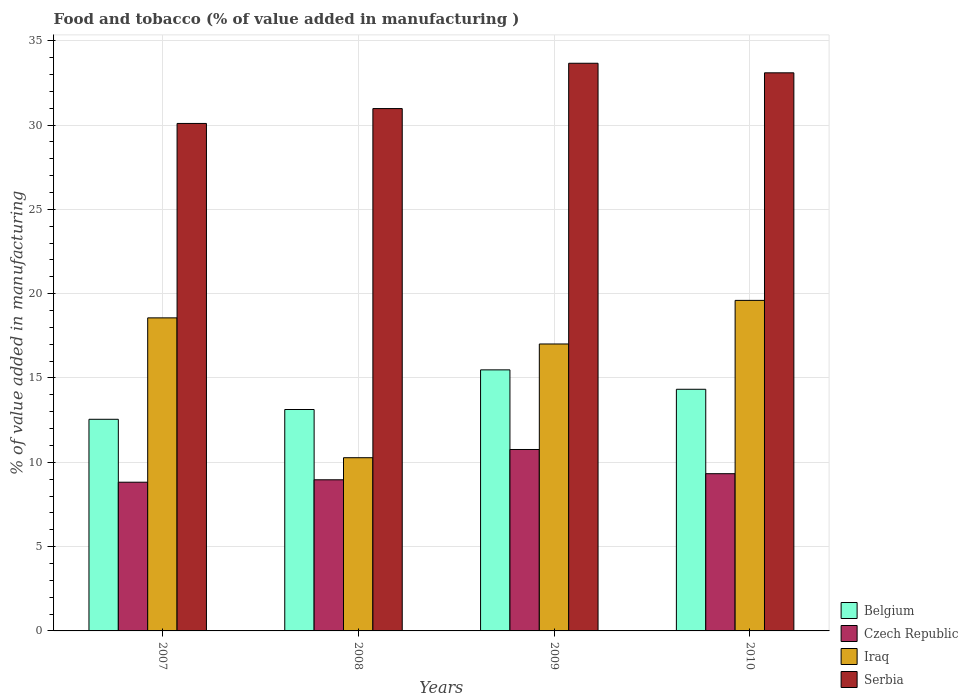Are the number of bars per tick equal to the number of legend labels?
Provide a succinct answer. Yes. How many bars are there on the 4th tick from the left?
Provide a succinct answer. 4. What is the value added in manufacturing food and tobacco in Iraq in 2009?
Your answer should be very brief. 17.02. Across all years, what is the maximum value added in manufacturing food and tobacco in Czech Republic?
Provide a short and direct response. 10.76. Across all years, what is the minimum value added in manufacturing food and tobacco in Czech Republic?
Make the answer very short. 8.82. What is the total value added in manufacturing food and tobacco in Czech Republic in the graph?
Provide a short and direct response. 37.86. What is the difference between the value added in manufacturing food and tobacco in Czech Republic in 2008 and that in 2010?
Provide a short and direct response. -0.36. What is the difference between the value added in manufacturing food and tobacco in Belgium in 2010 and the value added in manufacturing food and tobacco in Serbia in 2009?
Your response must be concise. -19.33. What is the average value added in manufacturing food and tobacco in Belgium per year?
Your answer should be very brief. 13.87. In the year 2008, what is the difference between the value added in manufacturing food and tobacco in Iraq and value added in manufacturing food and tobacco in Czech Republic?
Give a very brief answer. 1.31. What is the ratio of the value added in manufacturing food and tobacco in Czech Republic in 2007 to that in 2009?
Provide a succinct answer. 0.82. Is the value added in manufacturing food and tobacco in Belgium in 2008 less than that in 2009?
Offer a very short reply. Yes. Is the difference between the value added in manufacturing food and tobacco in Iraq in 2009 and 2010 greater than the difference between the value added in manufacturing food and tobacco in Czech Republic in 2009 and 2010?
Keep it short and to the point. No. What is the difference between the highest and the second highest value added in manufacturing food and tobacco in Belgium?
Your response must be concise. 1.15. What is the difference between the highest and the lowest value added in manufacturing food and tobacco in Belgium?
Your response must be concise. 2.93. In how many years, is the value added in manufacturing food and tobacco in Czech Republic greater than the average value added in manufacturing food and tobacco in Czech Republic taken over all years?
Your response must be concise. 1. Is it the case that in every year, the sum of the value added in manufacturing food and tobacco in Czech Republic and value added in manufacturing food and tobacco in Belgium is greater than the sum of value added in manufacturing food and tobacco in Iraq and value added in manufacturing food and tobacco in Serbia?
Your answer should be compact. Yes. What does the 1st bar from the left in 2009 represents?
Provide a succinct answer. Belgium. What does the 4th bar from the right in 2009 represents?
Give a very brief answer. Belgium. How many bars are there?
Offer a very short reply. 16. Are all the bars in the graph horizontal?
Make the answer very short. No. How many years are there in the graph?
Your answer should be very brief. 4. What is the difference between two consecutive major ticks on the Y-axis?
Your response must be concise. 5. Does the graph contain any zero values?
Your answer should be very brief. No. How are the legend labels stacked?
Provide a short and direct response. Vertical. What is the title of the graph?
Give a very brief answer. Food and tobacco (% of value added in manufacturing ). Does "Kenya" appear as one of the legend labels in the graph?
Your response must be concise. No. What is the label or title of the Y-axis?
Offer a very short reply. % of value added in manufacturing. What is the % of value added in manufacturing of Belgium in 2007?
Offer a terse response. 12.55. What is the % of value added in manufacturing of Czech Republic in 2007?
Offer a very short reply. 8.82. What is the % of value added in manufacturing of Iraq in 2007?
Offer a very short reply. 18.56. What is the % of value added in manufacturing of Serbia in 2007?
Your response must be concise. 30.09. What is the % of value added in manufacturing in Belgium in 2008?
Provide a succinct answer. 13.13. What is the % of value added in manufacturing in Czech Republic in 2008?
Provide a short and direct response. 8.96. What is the % of value added in manufacturing in Iraq in 2008?
Provide a succinct answer. 10.27. What is the % of value added in manufacturing in Serbia in 2008?
Make the answer very short. 30.97. What is the % of value added in manufacturing of Belgium in 2009?
Make the answer very short. 15.48. What is the % of value added in manufacturing of Czech Republic in 2009?
Your response must be concise. 10.76. What is the % of value added in manufacturing in Iraq in 2009?
Your response must be concise. 17.02. What is the % of value added in manufacturing in Serbia in 2009?
Your response must be concise. 33.66. What is the % of value added in manufacturing of Belgium in 2010?
Give a very brief answer. 14.33. What is the % of value added in manufacturing in Czech Republic in 2010?
Provide a short and direct response. 9.32. What is the % of value added in manufacturing of Iraq in 2010?
Your answer should be compact. 19.6. What is the % of value added in manufacturing in Serbia in 2010?
Your response must be concise. 33.09. Across all years, what is the maximum % of value added in manufacturing in Belgium?
Provide a succinct answer. 15.48. Across all years, what is the maximum % of value added in manufacturing in Czech Republic?
Give a very brief answer. 10.76. Across all years, what is the maximum % of value added in manufacturing of Iraq?
Provide a short and direct response. 19.6. Across all years, what is the maximum % of value added in manufacturing of Serbia?
Your answer should be compact. 33.66. Across all years, what is the minimum % of value added in manufacturing of Belgium?
Ensure brevity in your answer.  12.55. Across all years, what is the minimum % of value added in manufacturing in Czech Republic?
Make the answer very short. 8.82. Across all years, what is the minimum % of value added in manufacturing of Iraq?
Your response must be concise. 10.27. Across all years, what is the minimum % of value added in manufacturing of Serbia?
Your response must be concise. 30.09. What is the total % of value added in manufacturing of Belgium in the graph?
Offer a terse response. 55.49. What is the total % of value added in manufacturing of Czech Republic in the graph?
Your answer should be very brief. 37.86. What is the total % of value added in manufacturing in Iraq in the graph?
Keep it short and to the point. 65.45. What is the total % of value added in manufacturing in Serbia in the graph?
Offer a very short reply. 127.82. What is the difference between the % of value added in manufacturing of Belgium in 2007 and that in 2008?
Provide a succinct answer. -0.58. What is the difference between the % of value added in manufacturing of Czech Republic in 2007 and that in 2008?
Ensure brevity in your answer.  -0.14. What is the difference between the % of value added in manufacturing in Iraq in 2007 and that in 2008?
Offer a terse response. 8.29. What is the difference between the % of value added in manufacturing of Serbia in 2007 and that in 2008?
Ensure brevity in your answer.  -0.88. What is the difference between the % of value added in manufacturing in Belgium in 2007 and that in 2009?
Provide a succinct answer. -2.93. What is the difference between the % of value added in manufacturing of Czech Republic in 2007 and that in 2009?
Your answer should be very brief. -1.94. What is the difference between the % of value added in manufacturing in Iraq in 2007 and that in 2009?
Your answer should be compact. 1.55. What is the difference between the % of value added in manufacturing in Serbia in 2007 and that in 2009?
Your response must be concise. -3.57. What is the difference between the % of value added in manufacturing of Belgium in 2007 and that in 2010?
Give a very brief answer. -1.78. What is the difference between the % of value added in manufacturing of Czech Republic in 2007 and that in 2010?
Provide a succinct answer. -0.51. What is the difference between the % of value added in manufacturing of Iraq in 2007 and that in 2010?
Your answer should be very brief. -1.04. What is the difference between the % of value added in manufacturing of Serbia in 2007 and that in 2010?
Your answer should be very brief. -3. What is the difference between the % of value added in manufacturing of Belgium in 2008 and that in 2009?
Provide a short and direct response. -2.35. What is the difference between the % of value added in manufacturing in Czech Republic in 2008 and that in 2009?
Offer a very short reply. -1.8. What is the difference between the % of value added in manufacturing of Iraq in 2008 and that in 2009?
Your response must be concise. -6.74. What is the difference between the % of value added in manufacturing of Serbia in 2008 and that in 2009?
Give a very brief answer. -2.69. What is the difference between the % of value added in manufacturing in Belgium in 2008 and that in 2010?
Give a very brief answer. -1.2. What is the difference between the % of value added in manufacturing in Czech Republic in 2008 and that in 2010?
Provide a short and direct response. -0.36. What is the difference between the % of value added in manufacturing in Iraq in 2008 and that in 2010?
Your answer should be compact. -9.33. What is the difference between the % of value added in manufacturing of Serbia in 2008 and that in 2010?
Your answer should be very brief. -2.12. What is the difference between the % of value added in manufacturing in Belgium in 2009 and that in 2010?
Make the answer very short. 1.15. What is the difference between the % of value added in manufacturing of Czech Republic in 2009 and that in 2010?
Offer a very short reply. 1.43. What is the difference between the % of value added in manufacturing of Iraq in 2009 and that in 2010?
Offer a very short reply. -2.59. What is the difference between the % of value added in manufacturing of Serbia in 2009 and that in 2010?
Offer a terse response. 0.57. What is the difference between the % of value added in manufacturing in Belgium in 2007 and the % of value added in manufacturing in Czech Republic in 2008?
Your answer should be very brief. 3.59. What is the difference between the % of value added in manufacturing in Belgium in 2007 and the % of value added in manufacturing in Iraq in 2008?
Offer a very short reply. 2.28. What is the difference between the % of value added in manufacturing of Belgium in 2007 and the % of value added in manufacturing of Serbia in 2008?
Ensure brevity in your answer.  -18.43. What is the difference between the % of value added in manufacturing in Czech Republic in 2007 and the % of value added in manufacturing in Iraq in 2008?
Offer a terse response. -1.45. What is the difference between the % of value added in manufacturing in Czech Republic in 2007 and the % of value added in manufacturing in Serbia in 2008?
Offer a very short reply. -22.16. What is the difference between the % of value added in manufacturing of Iraq in 2007 and the % of value added in manufacturing of Serbia in 2008?
Your response must be concise. -12.41. What is the difference between the % of value added in manufacturing in Belgium in 2007 and the % of value added in manufacturing in Czech Republic in 2009?
Make the answer very short. 1.79. What is the difference between the % of value added in manufacturing in Belgium in 2007 and the % of value added in manufacturing in Iraq in 2009?
Make the answer very short. -4.47. What is the difference between the % of value added in manufacturing of Belgium in 2007 and the % of value added in manufacturing of Serbia in 2009?
Your answer should be very brief. -21.11. What is the difference between the % of value added in manufacturing of Czech Republic in 2007 and the % of value added in manufacturing of Iraq in 2009?
Make the answer very short. -8.2. What is the difference between the % of value added in manufacturing in Czech Republic in 2007 and the % of value added in manufacturing in Serbia in 2009?
Your answer should be compact. -24.84. What is the difference between the % of value added in manufacturing in Iraq in 2007 and the % of value added in manufacturing in Serbia in 2009?
Ensure brevity in your answer.  -15.1. What is the difference between the % of value added in manufacturing of Belgium in 2007 and the % of value added in manufacturing of Czech Republic in 2010?
Provide a short and direct response. 3.23. What is the difference between the % of value added in manufacturing of Belgium in 2007 and the % of value added in manufacturing of Iraq in 2010?
Ensure brevity in your answer.  -7.05. What is the difference between the % of value added in manufacturing in Belgium in 2007 and the % of value added in manufacturing in Serbia in 2010?
Provide a short and direct response. -20.55. What is the difference between the % of value added in manufacturing of Czech Republic in 2007 and the % of value added in manufacturing of Iraq in 2010?
Offer a very short reply. -10.78. What is the difference between the % of value added in manufacturing in Czech Republic in 2007 and the % of value added in manufacturing in Serbia in 2010?
Ensure brevity in your answer.  -24.28. What is the difference between the % of value added in manufacturing in Iraq in 2007 and the % of value added in manufacturing in Serbia in 2010?
Your answer should be compact. -14.53. What is the difference between the % of value added in manufacturing in Belgium in 2008 and the % of value added in manufacturing in Czech Republic in 2009?
Provide a succinct answer. 2.37. What is the difference between the % of value added in manufacturing in Belgium in 2008 and the % of value added in manufacturing in Iraq in 2009?
Your answer should be compact. -3.89. What is the difference between the % of value added in manufacturing in Belgium in 2008 and the % of value added in manufacturing in Serbia in 2009?
Your response must be concise. -20.53. What is the difference between the % of value added in manufacturing in Czech Republic in 2008 and the % of value added in manufacturing in Iraq in 2009?
Offer a very short reply. -8.05. What is the difference between the % of value added in manufacturing in Czech Republic in 2008 and the % of value added in manufacturing in Serbia in 2009?
Offer a terse response. -24.7. What is the difference between the % of value added in manufacturing of Iraq in 2008 and the % of value added in manufacturing of Serbia in 2009?
Your response must be concise. -23.39. What is the difference between the % of value added in manufacturing of Belgium in 2008 and the % of value added in manufacturing of Czech Republic in 2010?
Keep it short and to the point. 3.81. What is the difference between the % of value added in manufacturing in Belgium in 2008 and the % of value added in manufacturing in Iraq in 2010?
Ensure brevity in your answer.  -6.47. What is the difference between the % of value added in manufacturing in Belgium in 2008 and the % of value added in manufacturing in Serbia in 2010?
Your response must be concise. -19.96. What is the difference between the % of value added in manufacturing in Czech Republic in 2008 and the % of value added in manufacturing in Iraq in 2010?
Your answer should be very brief. -10.64. What is the difference between the % of value added in manufacturing of Czech Republic in 2008 and the % of value added in manufacturing of Serbia in 2010?
Make the answer very short. -24.13. What is the difference between the % of value added in manufacturing of Iraq in 2008 and the % of value added in manufacturing of Serbia in 2010?
Offer a terse response. -22.82. What is the difference between the % of value added in manufacturing of Belgium in 2009 and the % of value added in manufacturing of Czech Republic in 2010?
Ensure brevity in your answer.  6.16. What is the difference between the % of value added in manufacturing in Belgium in 2009 and the % of value added in manufacturing in Iraq in 2010?
Your answer should be compact. -4.12. What is the difference between the % of value added in manufacturing in Belgium in 2009 and the % of value added in manufacturing in Serbia in 2010?
Give a very brief answer. -17.61. What is the difference between the % of value added in manufacturing in Czech Republic in 2009 and the % of value added in manufacturing in Iraq in 2010?
Your answer should be very brief. -8.84. What is the difference between the % of value added in manufacturing in Czech Republic in 2009 and the % of value added in manufacturing in Serbia in 2010?
Your answer should be very brief. -22.34. What is the difference between the % of value added in manufacturing in Iraq in 2009 and the % of value added in manufacturing in Serbia in 2010?
Keep it short and to the point. -16.08. What is the average % of value added in manufacturing in Belgium per year?
Your response must be concise. 13.87. What is the average % of value added in manufacturing of Czech Republic per year?
Your response must be concise. 9.47. What is the average % of value added in manufacturing of Iraq per year?
Make the answer very short. 16.36. What is the average % of value added in manufacturing in Serbia per year?
Provide a short and direct response. 31.96. In the year 2007, what is the difference between the % of value added in manufacturing in Belgium and % of value added in manufacturing in Czech Republic?
Keep it short and to the point. 3.73. In the year 2007, what is the difference between the % of value added in manufacturing of Belgium and % of value added in manufacturing of Iraq?
Your answer should be very brief. -6.01. In the year 2007, what is the difference between the % of value added in manufacturing in Belgium and % of value added in manufacturing in Serbia?
Your answer should be very brief. -17.54. In the year 2007, what is the difference between the % of value added in manufacturing in Czech Republic and % of value added in manufacturing in Iraq?
Your response must be concise. -9.75. In the year 2007, what is the difference between the % of value added in manufacturing of Czech Republic and % of value added in manufacturing of Serbia?
Provide a short and direct response. -21.27. In the year 2007, what is the difference between the % of value added in manufacturing of Iraq and % of value added in manufacturing of Serbia?
Ensure brevity in your answer.  -11.53. In the year 2008, what is the difference between the % of value added in manufacturing of Belgium and % of value added in manufacturing of Czech Republic?
Offer a very short reply. 4.17. In the year 2008, what is the difference between the % of value added in manufacturing of Belgium and % of value added in manufacturing of Iraq?
Your response must be concise. 2.86. In the year 2008, what is the difference between the % of value added in manufacturing in Belgium and % of value added in manufacturing in Serbia?
Provide a short and direct response. -17.84. In the year 2008, what is the difference between the % of value added in manufacturing of Czech Republic and % of value added in manufacturing of Iraq?
Give a very brief answer. -1.31. In the year 2008, what is the difference between the % of value added in manufacturing in Czech Republic and % of value added in manufacturing in Serbia?
Make the answer very short. -22.01. In the year 2008, what is the difference between the % of value added in manufacturing in Iraq and % of value added in manufacturing in Serbia?
Keep it short and to the point. -20.7. In the year 2009, what is the difference between the % of value added in manufacturing of Belgium and % of value added in manufacturing of Czech Republic?
Give a very brief answer. 4.72. In the year 2009, what is the difference between the % of value added in manufacturing of Belgium and % of value added in manufacturing of Iraq?
Offer a very short reply. -1.53. In the year 2009, what is the difference between the % of value added in manufacturing of Belgium and % of value added in manufacturing of Serbia?
Your answer should be compact. -18.18. In the year 2009, what is the difference between the % of value added in manufacturing of Czech Republic and % of value added in manufacturing of Iraq?
Provide a short and direct response. -6.26. In the year 2009, what is the difference between the % of value added in manufacturing in Czech Republic and % of value added in manufacturing in Serbia?
Your answer should be very brief. -22.9. In the year 2009, what is the difference between the % of value added in manufacturing of Iraq and % of value added in manufacturing of Serbia?
Give a very brief answer. -16.65. In the year 2010, what is the difference between the % of value added in manufacturing in Belgium and % of value added in manufacturing in Czech Republic?
Offer a very short reply. 5.01. In the year 2010, what is the difference between the % of value added in manufacturing of Belgium and % of value added in manufacturing of Iraq?
Ensure brevity in your answer.  -5.27. In the year 2010, what is the difference between the % of value added in manufacturing in Belgium and % of value added in manufacturing in Serbia?
Provide a succinct answer. -18.77. In the year 2010, what is the difference between the % of value added in manufacturing of Czech Republic and % of value added in manufacturing of Iraq?
Offer a very short reply. -10.28. In the year 2010, what is the difference between the % of value added in manufacturing in Czech Republic and % of value added in manufacturing in Serbia?
Give a very brief answer. -23.77. In the year 2010, what is the difference between the % of value added in manufacturing in Iraq and % of value added in manufacturing in Serbia?
Your response must be concise. -13.49. What is the ratio of the % of value added in manufacturing of Belgium in 2007 to that in 2008?
Offer a terse response. 0.96. What is the ratio of the % of value added in manufacturing of Iraq in 2007 to that in 2008?
Keep it short and to the point. 1.81. What is the ratio of the % of value added in manufacturing in Serbia in 2007 to that in 2008?
Offer a very short reply. 0.97. What is the ratio of the % of value added in manufacturing in Belgium in 2007 to that in 2009?
Give a very brief answer. 0.81. What is the ratio of the % of value added in manufacturing in Czech Republic in 2007 to that in 2009?
Offer a terse response. 0.82. What is the ratio of the % of value added in manufacturing in Iraq in 2007 to that in 2009?
Provide a short and direct response. 1.09. What is the ratio of the % of value added in manufacturing in Serbia in 2007 to that in 2009?
Ensure brevity in your answer.  0.89. What is the ratio of the % of value added in manufacturing in Belgium in 2007 to that in 2010?
Your response must be concise. 0.88. What is the ratio of the % of value added in manufacturing in Czech Republic in 2007 to that in 2010?
Your answer should be very brief. 0.95. What is the ratio of the % of value added in manufacturing in Iraq in 2007 to that in 2010?
Provide a short and direct response. 0.95. What is the ratio of the % of value added in manufacturing of Serbia in 2007 to that in 2010?
Give a very brief answer. 0.91. What is the ratio of the % of value added in manufacturing in Belgium in 2008 to that in 2009?
Provide a succinct answer. 0.85. What is the ratio of the % of value added in manufacturing of Czech Republic in 2008 to that in 2009?
Give a very brief answer. 0.83. What is the ratio of the % of value added in manufacturing of Iraq in 2008 to that in 2009?
Offer a terse response. 0.6. What is the ratio of the % of value added in manufacturing of Serbia in 2008 to that in 2009?
Ensure brevity in your answer.  0.92. What is the ratio of the % of value added in manufacturing in Belgium in 2008 to that in 2010?
Offer a terse response. 0.92. What is the ratio of the % of value added in manufacturing in Czech Republic in 2008 to that in 2010?
Offer a terse response. 0.96. What is the ratio of the % of value added in manufacturing of Iraq in 2008 to that in 2010?
Keep it short and to the point. 0.52. What is the ratio of the % of value added in manufacturing of Serbia in 2008 to that in 2010?
Offer a terse response. 0.94. What is the ratio of the % of value added in manufacturing in Belgium in 2009 to that in 2010?
Provide a succinct answer. 1.08. What is the ratio of the % of value added in manufacturing of Czech Republic in 2009 to that in 2010?
Offer a very short reply. 1.15. What is the ratio of the % of value added in manufacturing in Iraq in 2009 to that in 2010?
Give a very brief answer. 0.87. What is the ratio of the % of value added in manufacturing in Serbia in 2009 to that in 2010?
Offer a terse response. 1.02. What is the difference between the highest and the second highest % of value added in manufacturing in Belgium?
Your answer should be very brief. 1.15. What is the difference between the highest and the second highest % of value added in manufacturing in Czech Republic?
Your answer should be very brief. 1.43. What is the difference between the highest and the second highest % of value added in manufacturing in Iraq?
Offer a terse response. 1.04. What is the difference between the highest and the second highest % of value added in manufacturing in Serbia?
Give a very brief answer. 0.57. What is the difference between the highest and the lowest % of value added in manufacturing of Belgium?
Make the answer very short. 2.93. What is the difference between the highest and the lowest % of value added in manufacturing in Czech Republic?
Make the answer very short. 1.94. What is the difference between the highest and the lowest % of value added in manufacturing of Iraq?
Your answer should be very brief. 9.33. What is the difference between the highest and the lowest % of value added in manufacturing of Serbia?
Keep it short and to the point. 3.57. 